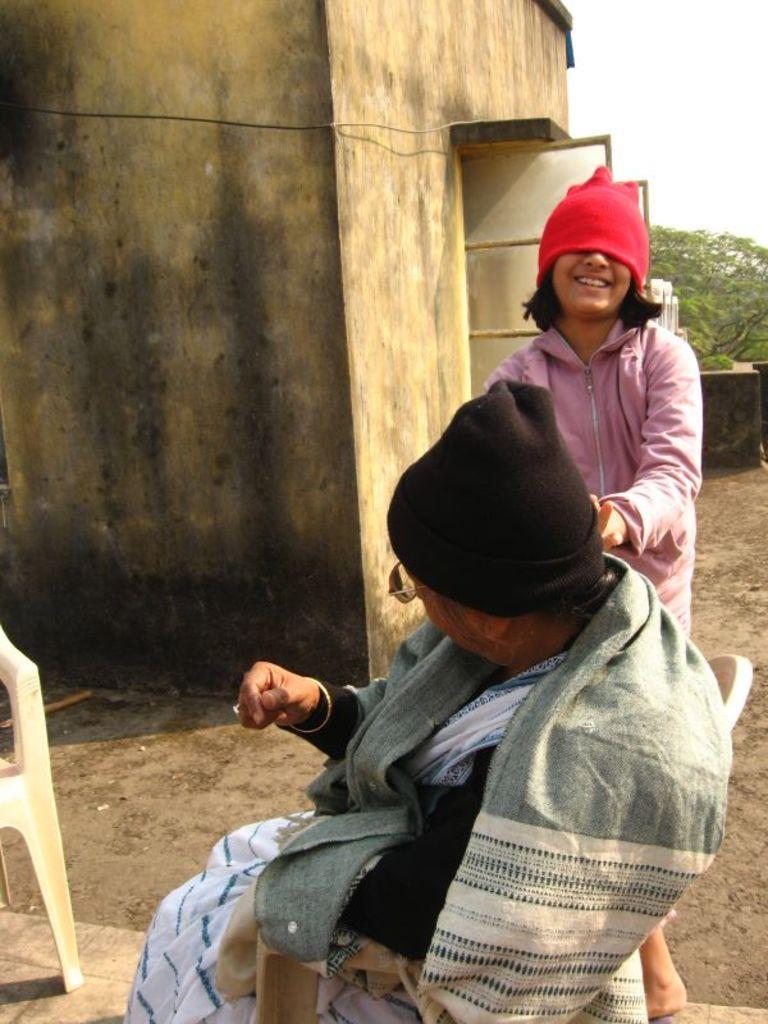Could you give a brief overview of what you see in this image? In this image we can see two persons. One person is wearing a cap and spectacles is sitting on a chair. One woman is standing. In the background, we can see a chair placed on the ground, building with windows, tree and the sky. 